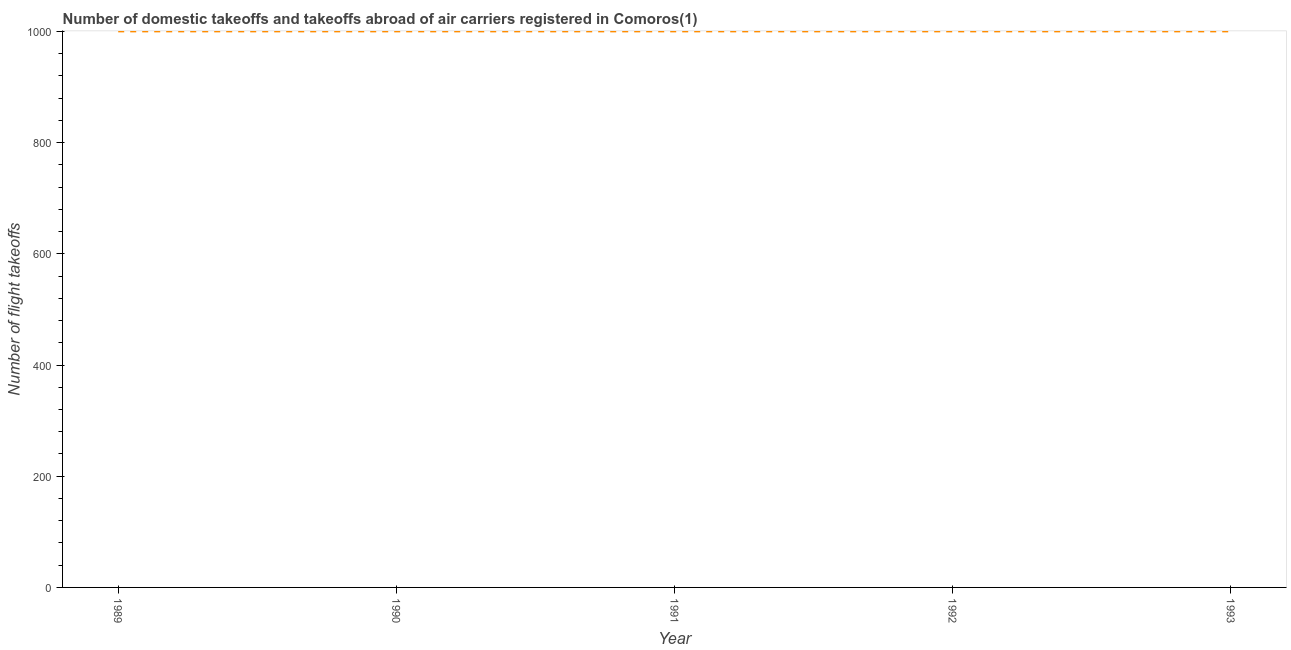What is the number of flight takeoffs in 1990?
Your answer should be very brief. 1000. Across all years, what is the maximum number of flight takeoffs?
Offer a terse response. 1000. Across all years, what is the minimum number of flight takeoffs?
Make the answer very short. 1000. In which year was the number of flight takeoffs maximum?
Keep it short and to the point. 1989. In which year was the number of flight takeoffs minimum?
Your answer should be compact. 1989. What is the sum of the number of flight takeoffs?
Your answer should be very brief. 5000. What is the difference between the number of flight takeoffs in 1989 and 1991?
Offer a very short reply. 0. What is the average number of flight takeoffs per year?
Give a very brief answer. 1000. In how many years, is the number of flight takeoffs greater than 640 ?
Give a very brief answer. 5. Do a majority of the years between 1990 and 1992 (inclusive) have number of flight takeoffs greater than 800 ?
Ensure brevity in your answer.  Yes. Is the number of flight takeoffs in 1991 less than that in 1993?
Provide a succinct answer. No. Is the sum of the number of flight takeoffs in 1990 and 1991 greater than the maximum number of flight takeoffs across all years?
Provide a succinct answer. Yes. What is the difference between the highest and the lowest number of flight takeoffs?
Your answer should be very brief. 0. How many lines are there?
Your answer should be very brief. 1. How many years are there in the graph?
Your answer should be compact. 5. What is the difference between two consecutive major ticks on the Y-axis?
Offer a very short reply. 200. Are the values on the major ticks of Y-axis written in scientific E-notation?
Your answer should be very brief. No. What is the title of the graph?
Provide a succinct answer. Number of domestic takeoffs and takeoffs abroad of air carriers registered in Comoros(1). What is the label or title of the Y-axis?
Provide a short and direct response. Number of flight takeoffs. What is the Number of flight takeoffs of 1993?
Your answer should be compact. 1000. What is the difference between the Number of flight takeoffs in 1989 and 1992?
Make the answer very short. 0. What is the difference between the Number of flight takeoffs in 1989 and 1993?
Your answer should be compact. 0. What is the difference between the Number of flight takeoffs in 1990 and 1991?
Ensure brevity in your answer.  0. What is the difference between the Number of flight takeoffs in 1990 and 1992?
Make the answer very short. 0. What is the difference between the Number of flight takeoffs in 1990 and 1993?
Keep it short and to the point. 0. What is the difference between the Number of flight takeoffs in 1991 and 1993?
Provide a short and direct response. 0. What is the difference between the Number of flight takeoffs in 1992 and 1993?
Your answer should be compact. 0. What is the ratio of the Number of flight takeoffs in 1990 to that in 1992?
Your answer should be compact. 1. What is the ratio of the Number of flight takeoffs in 1990 to that in 1993?
Provide a short and direct response. 1. What is the ratio of the Number of flight takeoffs in 1991 to that in 1992?
Your response must be concise. 1. What is the ratio of the Number of flight takeoffs in 1991 to that in 1993?
Keep it short and to the point. 1. 